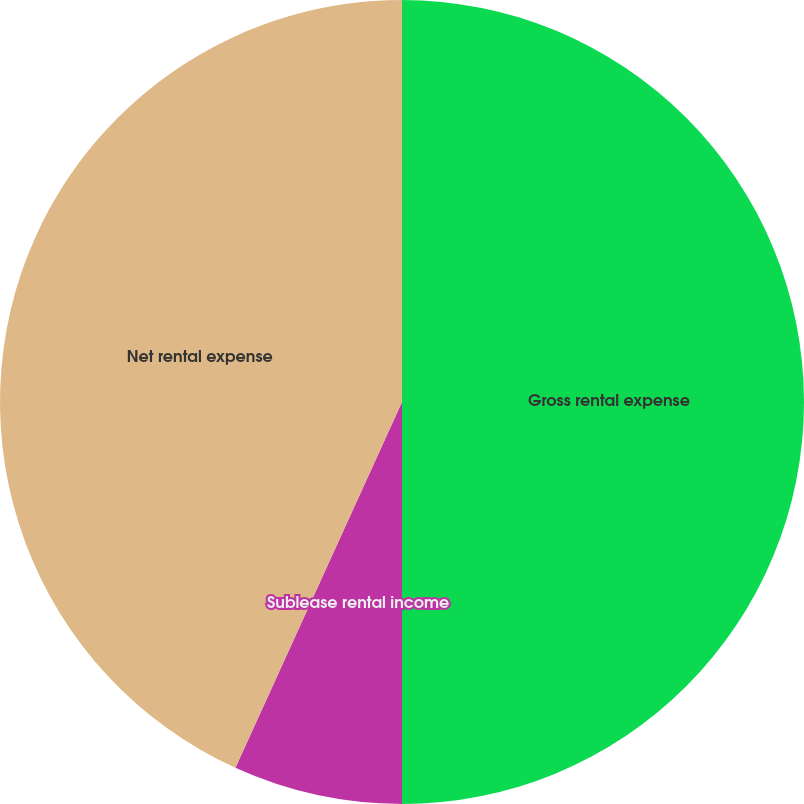<chart> <loc_0><loc_0><loc_500><loc_500><pie_chart><fcel>Gross rental expense<fcel>Sublease rental income<fcel>Net rental expense<nl><fcel>50.0%<fcel>6.8%<fcel>43.2%<nl></chart> 